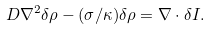Convert formula to latex. <formula><loc_0><loc_0><loc_500><loc_500>D \nabla ^ { 2 } \delta \rho - ( \sigma / \kappa ) \delta \rho = \nabla \cdot \delta { I } .</formula> 